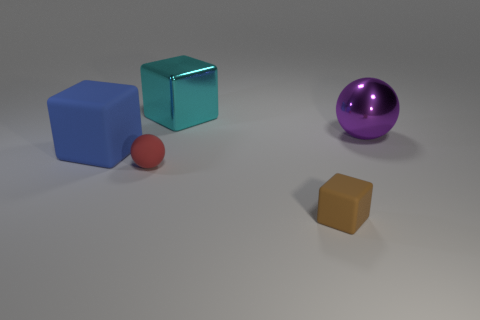Are there fewer small objects that are in front of the red matte ball than blocks that are on the left side of the small cube?
Your answer should be compact. Yes. The metal thing left of the object on the right side of the tiny rubber object right of the big cyan shiny block is what shape?
Offer a very short reply. Cube. How many metal things are either small blue balls or small brown cubes?
Offer a very short reply. 0. The big metal thing in front of the cube behind the matte block that is behind the small brown cube is what color?
Your answer should be very brief. Purple. What color is the other rubber object that is the same shape as the blue rubber object?
Make the answer very short. Brown. Is there anything else that is the same color as the small cube?
Your answer should be compact. No. How many other objects are there of the same material as the big blue cube?
Keep it short and to the point. 2. The red matte sphere is what size?
Your response must be concise. Small. Is there another big matte object of the same shape as the cyan object?
Make the answer very short. Yes. How many objects are either large cyan metal blocks or matte objects behind the red sphere?
Provide a short and direct response. 2. 